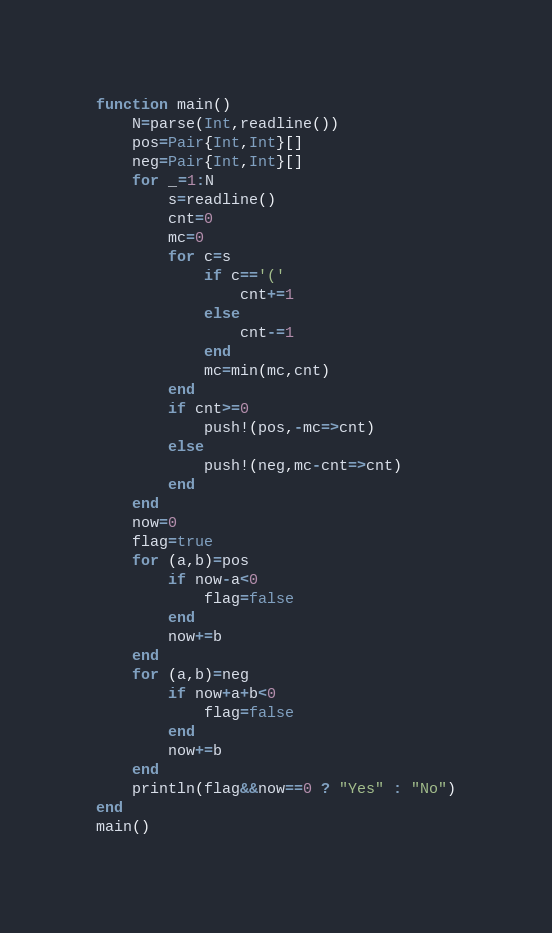<code> <loc_0><loc_0><loc_500><loc_500><_Julia_>function main()
	N=parse(Int,readline())
	pos=Pair{Int,Int}[]
	neg=Pair{Int,Int}[]
	for _=1:N
		s=readline()
		cnt=0
		mc=0
		for c=s
			if c=='('
				cnt+=1
			else
				cnt-=1
			end
			mc=min(mc,cnt)
		end
		if cnt>=0
			push!(pos,-mc=>cnt)
		else
			push!(neg,mc-cnt=>cnt)
		end
	end
	now=0
	flag=true
	for (a,b)=pos
		if now-a<0
			flag=false
		end
		now+=b
	end
	for (a,b)=neg
		if now+a+b<0
			flag=false
		end
		now+=b
	end
	println(flag&&now==0 ? "Yes" : "No")
end
main()
</code> 